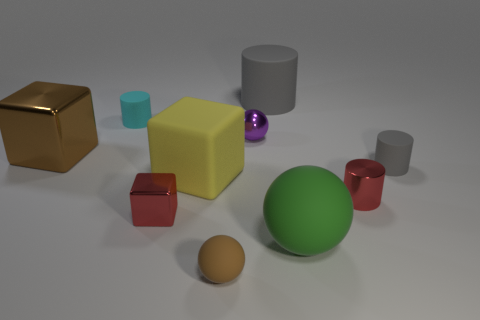Subtract all small spheres. How many spheres are left? 1 Subtract all gray cylinders. How many cylinders are left? 2 Subtract all gray spheres. How many gray cylinders are left? 2 Subtract all cubes. How many objects are left? 7 Subtract 1 cubes. How many cubes are left? 2 Subtract 0 gray balls. How many objects are left? 10 Subtract all purple blocks. Subtract all blue balls. How many blocks are left? 3 Subtract all big blocks. Subtract all gray cylinders. How many objects are left? 6 Add 2 rubber cylinders. How many rubber cylinders are left? 5 Add 5 green rubber cylinders. How many green rubber cylinders exist? 5 